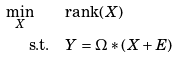Convert formula to latex. <formula><loc_0><loc_0><loc_500><loc_500>\min _ { X } \quad & \text {rank} ( X ) \\ \text {s.t.} \quad & Y = \Omega \ast ( X + E )</formula> 